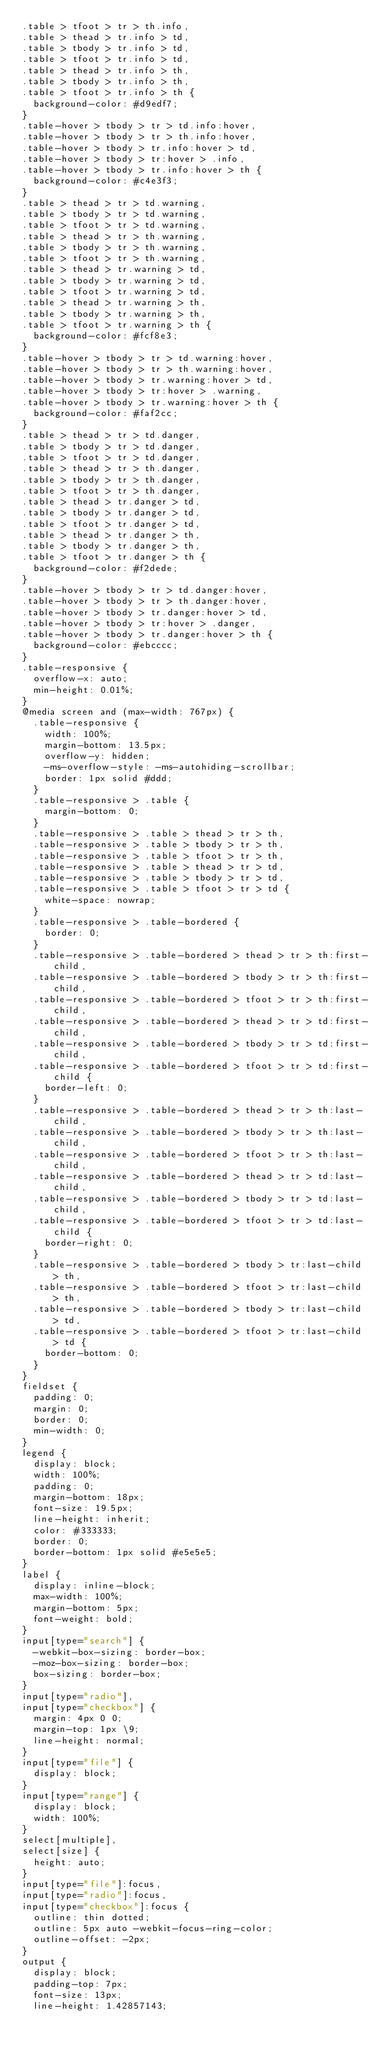<code> <loc_0><loc_0><loc_500><loc_500><_HTML_>.table > tfoot > tr > th.info,
.table > thead > tr.info > td,
.table > tbody > tr.info > td,
.table > tfoot > tr.info > td,
.table > thead > tr.info > th,
.table > tbody > tr.info > th,
.table > tfoot > tr.info > th {
  background-color: #d9edf7;
}
.table-hover > tbody > tr > td.info:hover,
.table-hover > tbody > tr > th.info:hover,
.table-hover > tbody > tr.info:hover > td,
.table-hover > tbody > tr:hover > .info,
.table-hover > tbody > tr.info:hover > th {
  background-color: #c4e3f3;
}
.table > thead > tr > td.warning,
.table > tbody > tr > td.warning,
.table > tfoot > tr > td.warning,
.table > thead > tr > th.warning,
.table > tbody > tr > th.warning,
.table > tfoot > tr > th.warning,
.table > thead > tr.warning > td,
.table > tbody > tr.warning > td,
.table > tfoot > tr.warning > td,
.table > thead > tr.warning > th,
.table > tbody > tr.warning > th,
.table > tfoot > tr.warning > th {
  background-color: #fcf8e3;
}
.table-hover > tbody > tr > td.warning:hover,
.table-hover > tbody > tr > th.warning:hover,
.table-hover > tbody > tr.warning:hover > td,
.table-hover > tbody > tr:hover > .warning,
.table-hover > tbody > tr.warning:hover > th {
  background-color: #faf2cc;
}
.table > thead > tr > td.danger,
.table > tbody > tr > td.danger,
.table > tfoot > tr > td.danger,
.table > thead > tr > th.danger,
.table > tbody > tr > th.danger,
.table > tfoot > tr > th.danger,
.table > thead > tr.danger > td,
.table > tbody > tr.danger > td,
.table > tfoot > tr.danger > td,
.table > thead > tr.danger > th,
.table > tbody > tr.danger > th,
.table > tfoot > tr.danger > th {
  background-color: #f2dede;
}
.table-hover > tbody > tr > td.danger:hover,
.table-hover > tbody > tr > th.danger:hover,
.table-hover > tbody > tr.danger:hover > td,
.table-hover > tbody > tr:hover > .danger,
.table-hover > tbody > tr.danger:hover > th {
  background-color: #ebcccc;
}
.table-responsive {
  overflow-x: auto;
  min-height: 0.01%;
}
@media screen and (max-width: 767px) {
  .table-responsive {
    width: 100%;
    margin-bottom: 13.5px;
    overflow-y: hidden;
    -ms-overflow-style: -ms-autohiding-scrollbar;
    border: 1px solid #ddd;
  }
  .table-responsive > .table {
    margin-bottom: 0;
  }
  .table-responsive > .table > thead > tr > th,
  .table-responsive > .table > tbody > tr > th,
  .table-responsive > .table > tfoot > tr > th,
  .table-responsive > .table > thead > tr > td,
  .table-responsive > .table > tbody > tr > td,
  .table-responsive > .table > tfoot > tr > td {
    white-space: nowrap;
  }
  .table-responsive > .table-bordered {
    border: 0;
  }
  .table-responsive > .table-bordered > thead > tr > th:first-child,
  .table-responsive > .table-bordered > tbody > tr > th:first-child,
  .table-responsive > .table-bordered > tfoot > tr > th:first-child,
  .table-responsive > .table-bordered > thead > tr > td:first-child,
  .table-responsive > .table-bordered > tbody > tr > td:first-child,
  .table-responsive > .table-bordered > tfoot > tr > td:first-child {
    border-left: 0;
  }
  .table-responsive > .table-bordered > thead > tr > th:last-child,
  .table-responsive > .table-bordered > tbody > tr > th:last-child,
  .table-responsive > .table-bordered > tfoot > tr > th:last-child,
  .table-responsive > .table-bordered > thead > tr > td:last-child,
  .table-responsive > .table-bordered > tbody > tr > td:last-child,
  .table-responsive > .table-bordered > tfoot > tr > td:last-child {
    border-right: 0;
  }
  .table-responsive > .table-bordered > tbody > tr:last-child > th,
  .table-responsive > .table-bordered > tfoot > tr:last-child > th,
  .table-responsive > .table-bordered > tbody > tr:last-child > td,
  .table-responsive > .table-bordered > tfoot > tr:last-child > td {
    border-bottom: 0;
  }
}
fieldset {
  padding: 0;
  margin: 0;
  border: 0;
  min-width: 0;
}
legend {
  display: block;
  width: 100%;
  padding: 0;
  margin-bottom: 18px;
  font-size: 19.5px;
  line-height: inherit;
  color: #333333;
  border: 0;
  border-bottom: 1px solid #e5e5e5;
}
label {
  display: inline-block;
  max-width: 100%;
  margin-bottom: 5px;
  font-weight: bold;
}
input[type="search"] {
  -webkit-box-sizing: border-box;
  -moz-box-sizing: border-box;
  box-sizing: border-box;
}
input[type="radio"],
input[type="checkbox"] {
  margin: 4px 0 0;
  margin-top: 1px \9;
  line-height: normal;
}
input[type="file"] {
  display: block;
}
input[type="range"] {
  display: block;
  width: 100%;
}
select[multiple],
select[size] {
  height: auto;
}
input[type="file"]:focus,
input[type="radio"]:focus,
input[type="checkbox"]:focus {
  outline: thin dotted;
  outline: 5px auto -webkit-focus-ring-color;
  outline-offset: -2px;
}
output {
  display: block;
  padding-top: 7px;
  font-size: 13px;
  line-height: 1.42857143;</code> 